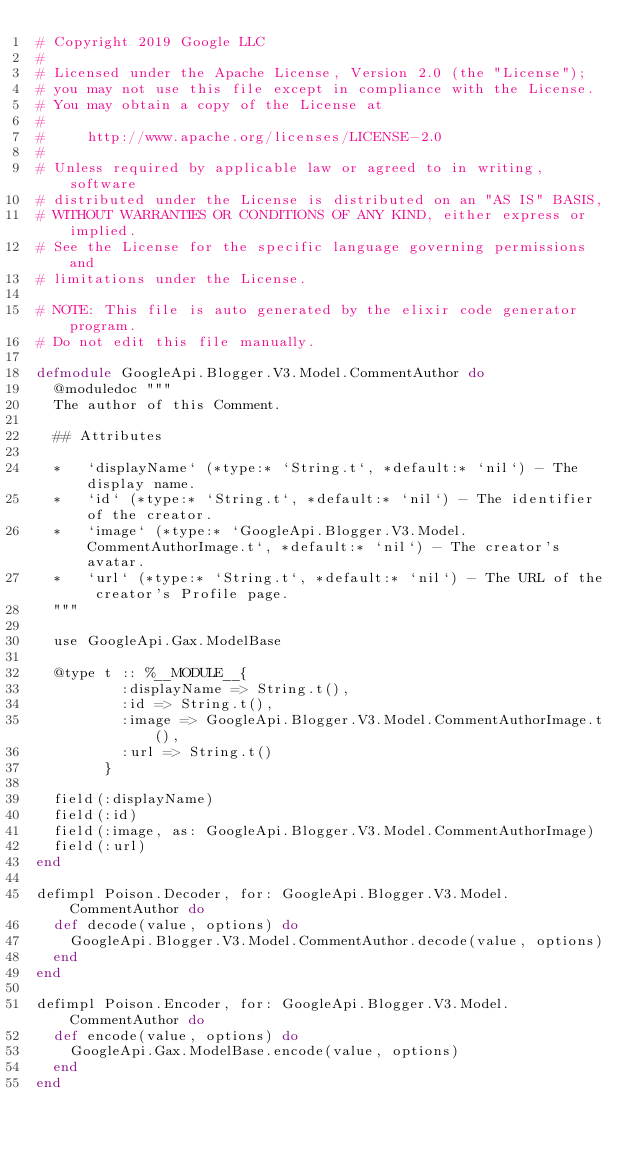<code> <loc_0><loc_0><loc_500><loc_500><_Elixir_># Copyright 2019 Google LLC
#
# Licensed under the Apache License, Version 2.0 (the "License");
# you may not use this file except in compliance with the License.
# You may obtain a copy of the License at
#
#     http://www.apache.org/licenses/LICENSE-2.0
#
# Unless required by applicable law or agreed to in writing, software
# distributed under the License is distributed on an "AS IS" BASIS,
# WITHOUT WARRANTIES OR CONDITIONS OF ANY KIND, either express or implied.
# See the License for the specific language governing permissions and
# limitations under the License.

# NOTE: This file is auto generated by the elixir code generator program.
# Do not edit this file manually.

defmodule GoogleApi.Blogger.V3.Model.CommentAuthor do
  @moduledoc """
  The author of this Comment.

  ## Attributes

  *   `displayName` (*type:* `String.t`, *default:* `nil`) - The display name.
  *   `id` (*type:* `String.t`, *default:* `nil`) - The identifier of the creator.
  *   `image` (*type:* `GoogleApi.Blogger.V3.Model.CommentAuthorImage.t`, *default:* `nil`) - The creator's avatar.
  *   `url` (*type:* `String.t`, *default:* `nil`) - The URL of the creator's Profile page.
  """

  use GoogleApi.Gax.ModelBase

  @type t :: %__MODULE__{
          :displayName => String.t(),
          :id => String.t(),
          :image => GoogleApi.Blogger.V3.Model.CommentAuthorImage.t(),
          :url => String.t()
        }

  field(:displayName)
  field(:id)
  field(:image, as: GoogleApi.Blogger.V3.Model.CommentAuthorImage)
  field(:url)
end

defimpl Poison.Decoder, for: GoogleApi.Blogger.V3.Model.CommentAuthor do
  def decode(value, options) do
    GoogleApi.Blogger.V3.Model.CommentAuthor.decode(value, options)
  end
end

defimpl Poison.Encoder, for: GoogleApi.Blogger.V3.Model.CommentAuthor do
  def encode(value, options) do
    GoogleApi.Gax.ModelBase.encode(value, options)
  end
end
</code> 